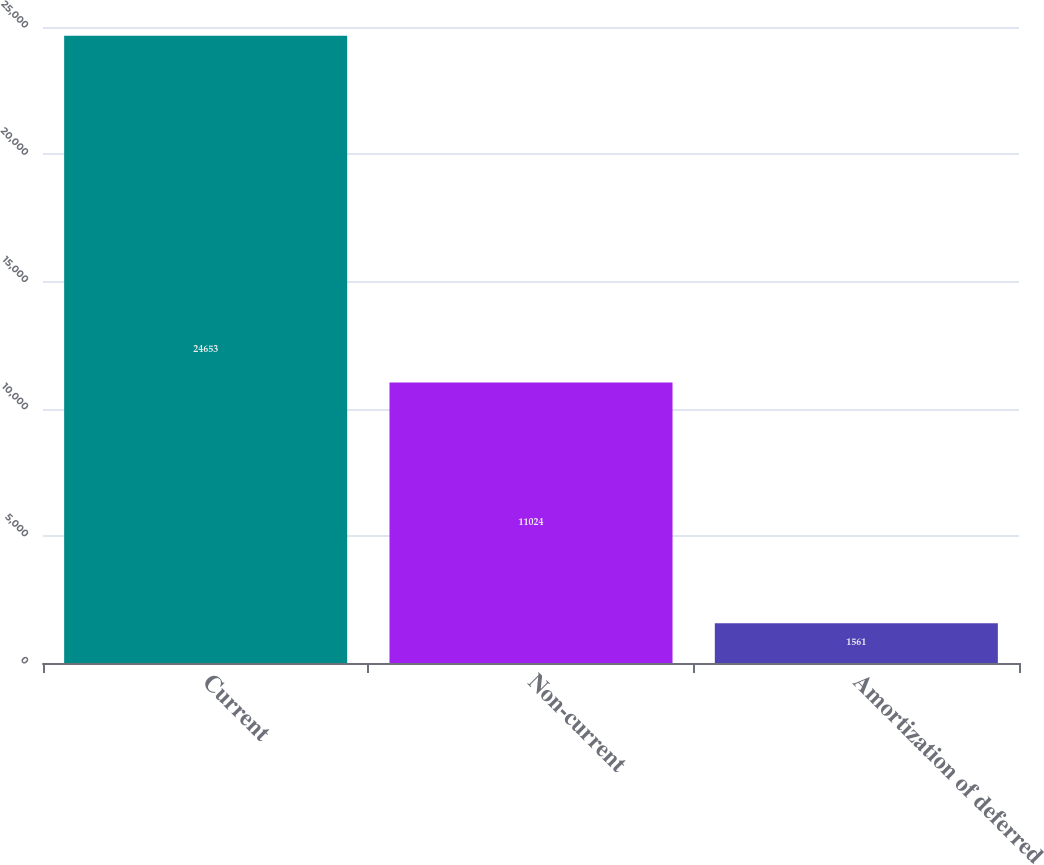Convert chart. <chart><loc_0><loc_0><loc_500><loc_500><bar_chart><fcel>Current<fcel>Non-current<fcel>Amortization of deferred<nl><fcel>24653<fcel>11024<fcel>1561<nl></chart> 